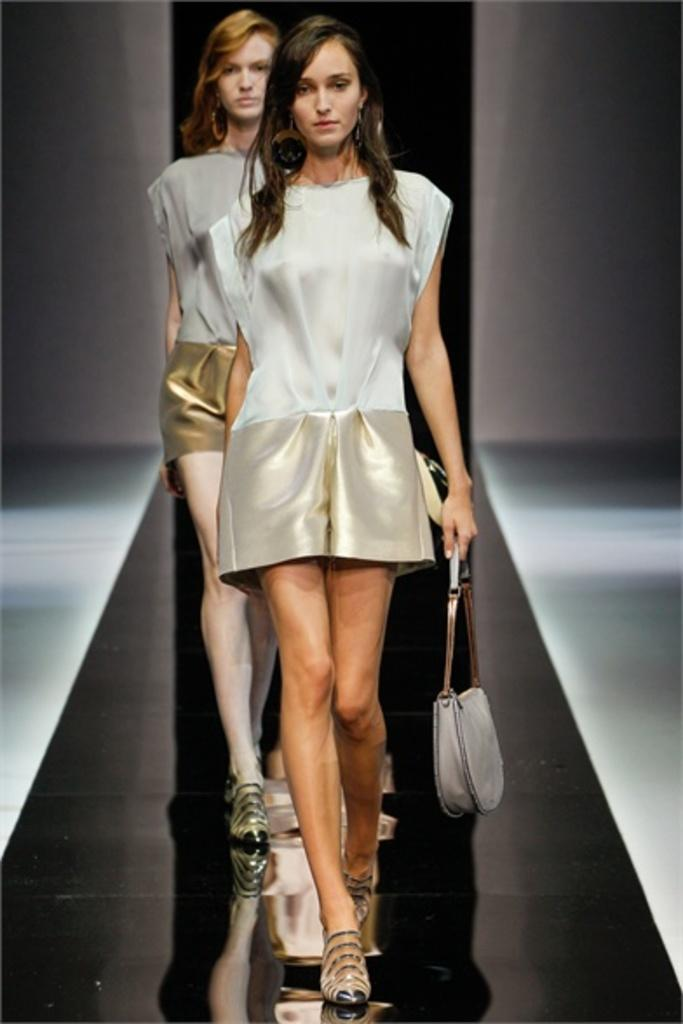How many people are in the image? There are two women in the image. What are the women doing in the image? The women are walking on a ramp. What are the women carrying with them? The women are holding handbags. How many boys are present in the image? There are no boys present in the image; it features two women. What type of crush can be seen in the image? There is no crush present in the image. 